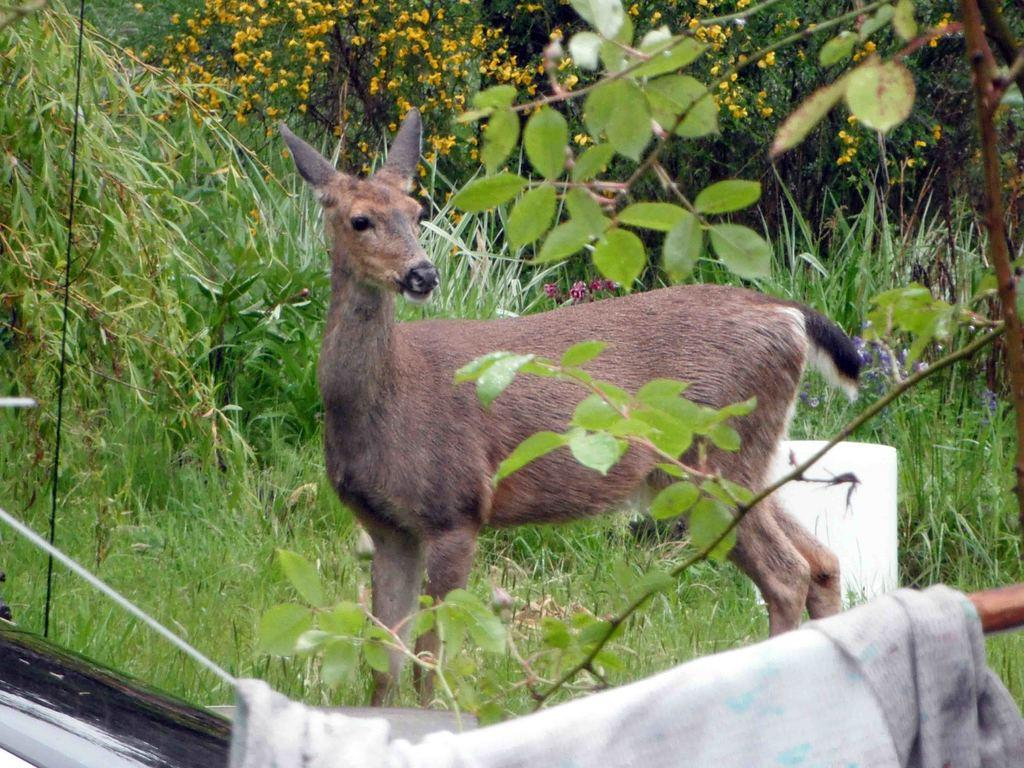What type of barrier can be seen in the image? There is a fence in the image. What type of vegetation is present in the image? There is grass, plants, and trees in the image. What animal can be seen on the grass in the image? There is a deer on the grass in the image. When might this image have been taken, based on the lighting? The image appears to have been taken during the day. What type of wool is the bear wearing in the image? There is no bear or wool present in the image. What historical event is depicted in the image? There is no historical event depicted in the image; it features a deer on grass with a fence, plants, and trees in the background. 